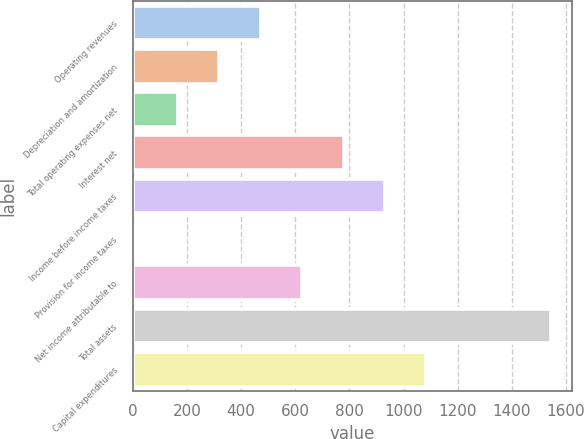Convert chart to OTSL. <chart><loc_0><loc_0><loc_500><loc_500><bar_chart><fcel>Operating revenues<fcel>Depreciation and amortization<fcel>Total operating expenses net<fcel>Interest net<fcel>Income before income taxes<fcel>Provision for income taxes<fcel>Net income attributable to<fcel>Total assets<fcel>Capital expenditures<nl><fcel>472.3<fcel>319.2<fcel>166.1<fcel>778.5<fcel>931.6<fcel>13<fcel>625.4<fcel>1544<fcel>1084.7<nl></chart> 